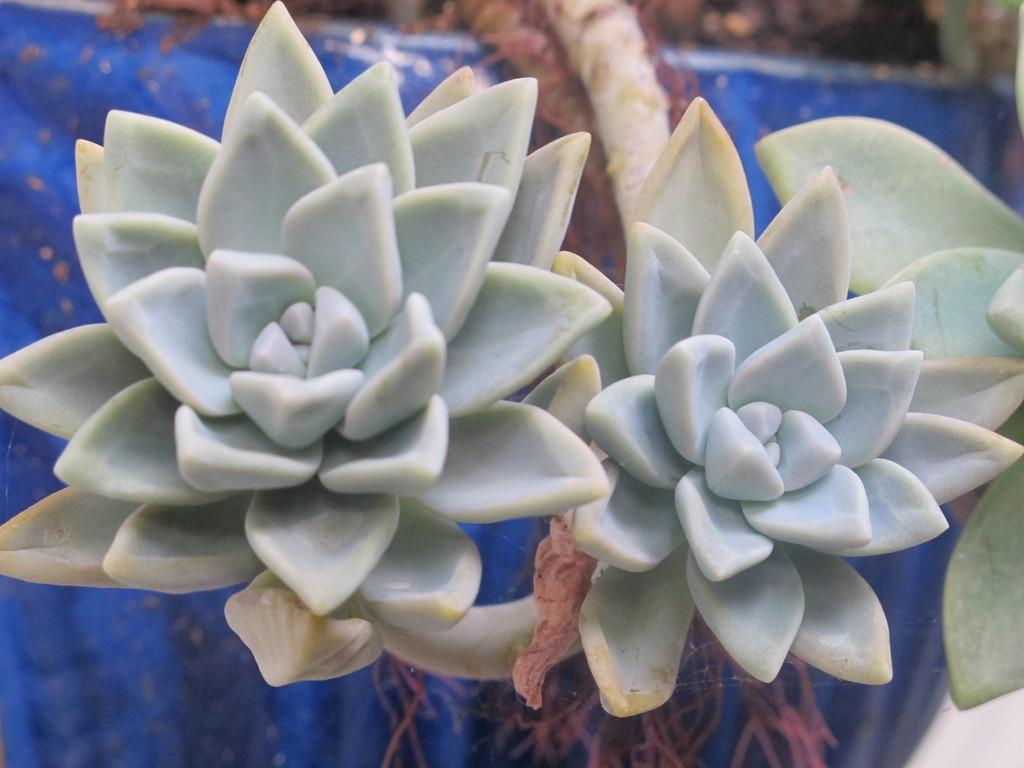What type of plants can be seen in the image? There are flowers in the image. What colors are the flowers? The flowers are blue and green in color. How are the flowers connected to the tree? The flowers are attached to a tree. What color is the background of the image? The background of the image is blue. What type of fact can be seen in the image? There is no fact present in the image; it features flowers attached to a tree with a blue background. How does the sack contribute to the image? There is no sack present in the image. 